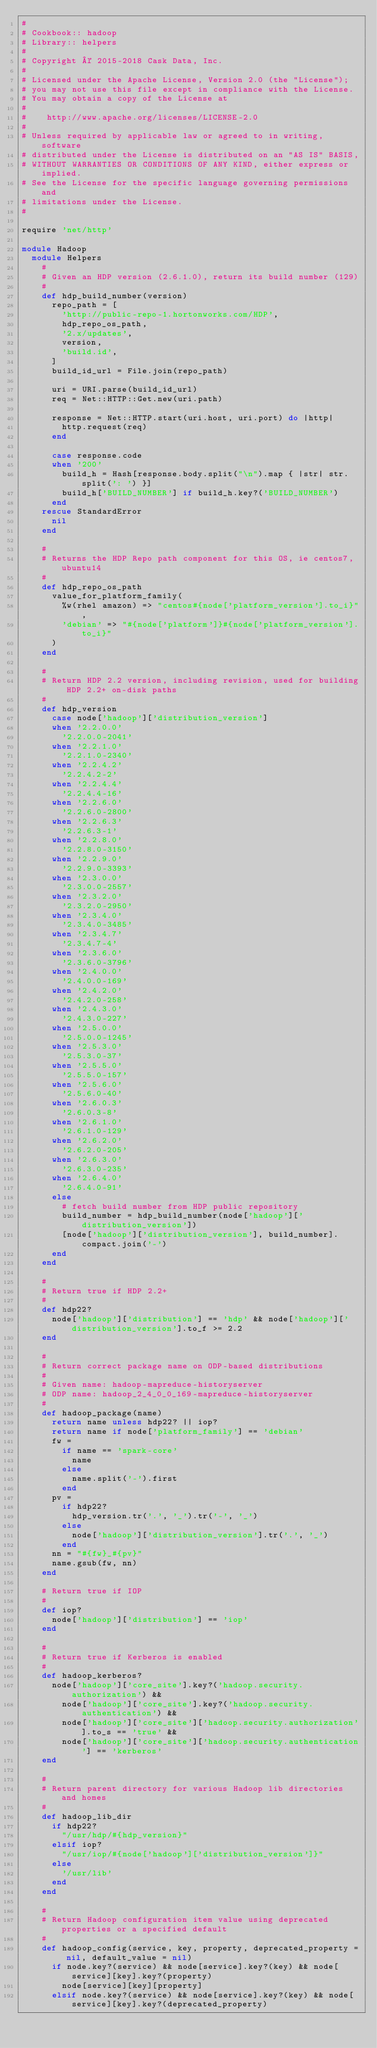Convert code to text. <code><loc_0><loc_0><loc_500><loc_500><_Ruby_>#
# Cookbook:: hadoop
# Library:: helpers
#
# Copyright © 2015-2018 Cask Data, Inc.
#
# Licensed under the Apache License, Version 2.0 (the "License");
# you may not use this file except in compliance with the License.
# You may obtain a copy of the License at
#
#    http://www.apache.org/licenses/LICENSE-2.0
#
# Unless required by applicable law or agreed to in writing, software
# distributed under the License is distributed on an "AS IS" BASIS,
# WITHOUT WARRANTIES OR CONDITIONS OF ANY KIND, either express or implied.
# See the License for the specific language governing permissions and
# limitations under the License.
#

require 'net/http'

module Hadoop
  module Helpers
    #
    # Given an HDP version (2.6.1.0), return its build number (129)
    #
    def hdp_build_number(version)
      repo_path = [
        'http://public-repo-1.hortonworks.com/HDP',
        hdp_repo_os_path,
        '2.x/updates',
        version,
        'build.id',
      ]
      build_id_url = File.join(repo_path)

      uri = URI.parse(build_id_url)
      req = Net::HTTP::Get.new(uri.path)

      response = Net::HTTP.start(uri.host, uri.port) do |http|
        http.request(req)
      end

      case response.code
      when '200'
        build_h = Hash[response.body.split("\n").map { |str| str.split(': ') }]
        build_h['BUILD_NUMBER'] if build_h.key?('BUILD_NUMBER')
      end
    rescue StandardError
      nil
    end

    #
    # Returns the HDP Repo path component for this OS, ie centos7, ubuntu14
    #
    def hdp_repo_os_path
      value_for_platform_family(
        %w(rhel amazon) => "centos#{node['platform_version'].to_i}",
        'debian' => "#{node['platform']}#{node['platform_version'].to_i}"
      )
    end

    #
    # Return HDP 2.2 version, including revision, used for building HDP 2.2+ on-disk paths
    #
    def hdp_version
      case node['hadoop']['distribution_version']
      when '2.2.0.0'
        '2.2.0.0-2041'
      when '2.2.1.0'
        '2.2.1.0-2340'
      when '2.2.4.2'
        '2.2.4.2-2'
      when '2.2.4.4'
        '2.2.4.4-16'
      when '2.2.6.0'
        '2.2.6.0-2800'
      when '2.2.6.3'
        '2.2.6.3-1'
      when '2.2.8.0'
        '2.2.8.0-3150'
      when '2.2.9.0'
        '2.2.9.0-3393'
      when '2.3.0.0'
        '2.3.0.0-2557'
      when '2.3.2.0'
        '2.3.2.0-2950'
      when '2.3.4.0'
        '2.3.4.0-3485'
      when '2.3.4.7'
        '2.3.4.7-4'
      when '2.3.6.0'
        '2.3.6.0-3796'
      when '2.4.0.0'
        '2.4.0.0-169'
      when '2.4.2.0'
        '2.4.2.0-258'
      when '2.4.3.0'
        '2.4.3.0-227'
      when '2.5.0.0'
        '2.5.0.0-1245'
      when '2.5.3.0'
        '2.5.3.0-37'
      when '2.5.5.0'
        '2.5.5.0-157'
      when '2.5.6.0'
        '2.5.6.0-40'
      when '2.6.0.3'
        '2.6.0.3-8'
      when '2.6.1.0'
        '2.6.1.0-129'
      when '2.6.2.0'
        '2.6.2.0-205'
      when '2.6.3.0'
        '2.6.3.0-235'
      when '2.6.4.0'
        '2.6.4.0-91'
      else
        # fetch build number from HDP public repository
        build_number = hdp_build_number(node['hadoop']['distribution_version'])
        [node['hadoop']['distribution_version'], build_number].compact.join('-')
      end
    end

    #
    # Return true if HDP 2.2+
    #
    def hdp22?
      node['hadoop']['distribution'] == 'hdp' && node['hadoop']['distribution_version'].to_f >= 2.2
    end

    #
    # Return correct package name on ODP-based distributions
    #
    # Given name: hadoop-mapreduce-historyserver
    # ODP name: hadoop_2_4_0_0_169-mapreduce-historyserver
    #
    def hadoop_package(name)
      return name unless hdp22? || iop?
      return name if node['platform_family'] == 'debian'
      fw =
        if name == 'spark-core'
          name
        else
          name.split('-').first
        end
      pv =
        if hdp22?
          hdp_version.tr('.', '_').tr('-', '_')
        else
          node['hadoop']['distribution_version'].tr('.', '_')
        end
      nn = "#{fw}_#{pv}"
      name.gsub(fw, nn)
    end

    # Return true if IOP
    #
    def iop?
      node['hadoop']['distribution'] == 'iop'
    end

    #
    # Return true if Kerberos is enabled
    #
    def hadoop_kerberos?
      node['hadoop']['core_site'].key?('hadoop.security.authorization') &&
        node['hadoop']['core_site'].key?('hadoop.security.authentication') &&
        node['hadoop']['core_site']['hadoop.security.authorization'].to_s == 'true' &&
        node['hadoop']['core_site']['hadoop.security.authentication'] == 'kerberos'
    end

    #
    # Return parent directory for various Hadoop lib directories and homes
    #
    def hadoop_lib_dir
      if hdp22?
        "/usr/hdp/#{hdp_version}"
      elsif iop?
        "/usr/iop/#{node['hadoop']['distribution_version']}"
      else
        '/usr/lib'
      end
    end

    #
    # Return Hadoop configuration item value using deprecated properties or a specified default
    #
    def hadoop_config(service, key, property, deprecated_property = nil, default_value = nil)
      if node.key?(service) && node[service].key?(key) && node[service][key].key?(property)
        node[service][key][property]
      elsif node.key?(service) && node[service].key?(key) && node[service][key].key?(deprecated_property)</code> 